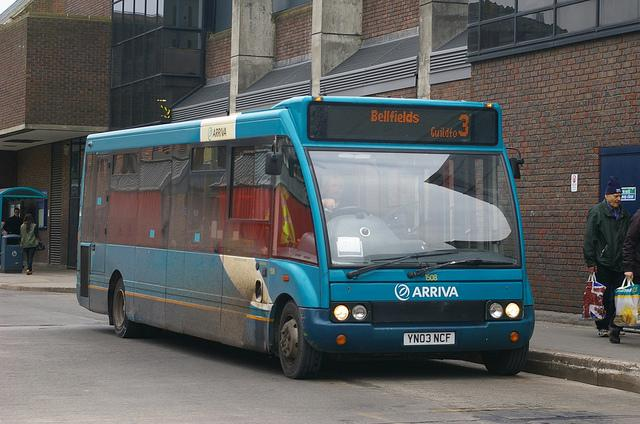How was the man able to get the plastic bags he is carrying? Please explain your reasoning. by shopping. The bags are advertising the store name that it was bought from. 